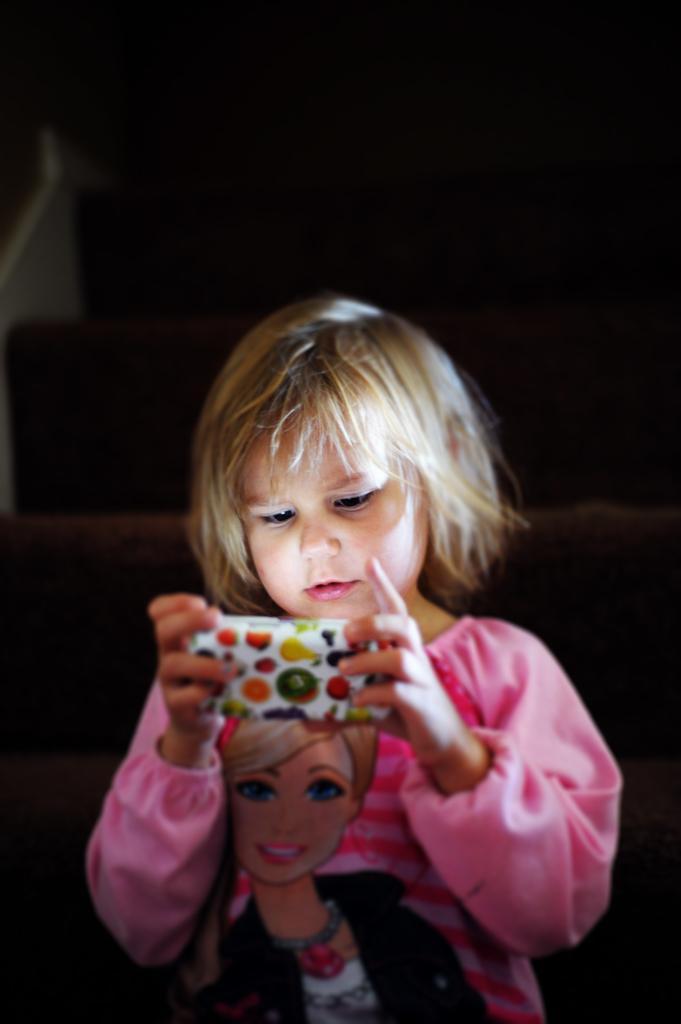Describe this image in one or two sentences. In this image there is a girl holding the mobile and the background of the image is dark. 